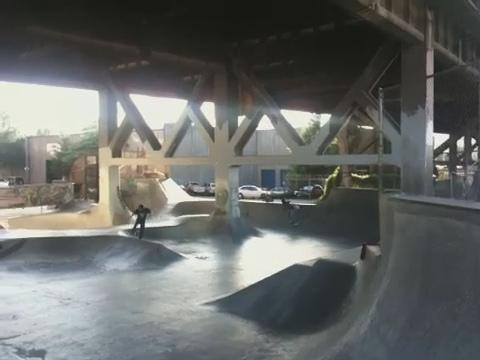Why are there mounds on the surface?

Choices:
A) for tricks
B) for grazing
C) for barriers
D) for gardening for tricks 